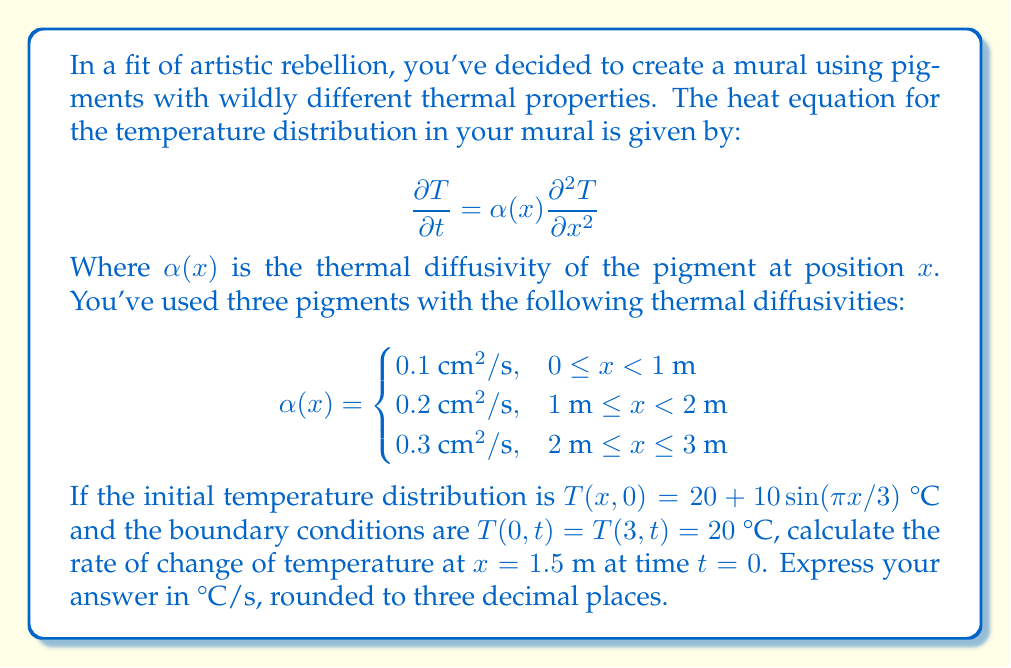Can you answer this question? Let's approach this step-by-step:

1) The rate of change of temperature is given by the left side of the heat equation:

   $$\frac{\partial T}{\partial t} = \alpha(x) \frac{\partial^2 T}{\partial x^2}$$

2) We need to calculate $\frac{\partial^2 T}{\partial x^2}$ at $x = 1.5$ m and $t = 0$.

3) The initial temperature distribution is:
   
   $$T(x,0) = 20 + 10\sin(\pi x/3)$$

4) To find $\frac{\partial^2 T}{\partial x^2}$, we need to differentiate this twice with respect to $x$:

   $$\frac{\partial T}{\partial x} = 10 \cdot \frac{\pi}{3} \cos(\pi x/3)$$
   
   $$\frac{\partial^2 T}{\partial x^2} = 10 \cdot (\frac{\pi}{3})^2 \cdot (-\sin(\pi x/3))$$

5) At $x = 1.5$ m:

   $$\frac{\partial^2 T}{\partial x^2} = 10 \cdot (\frac{\pi}{3})^2 \cdot (-\sin(\pi \cdot 1.5/3))$$
   $$= 10 \cdot (\frac{\pi}{3})^2 \cdot (-\sin(\pi/2))$$
   $$= -10 \cdot (\frac{\pi}{3})^2 \approx -3.290 \text{ °C/m}^2$$

6) At $x = 1.5$ m, we're in the second region where $\alpha(x) = 0.2 \text{ cm}^2/\text{s} = 0.00002 \text{ m}^2/\text{s}$

7) Therefore, the rate of change of temperature is:

   $$\frac{\partial T}{\partial t} = 0.00002 \cdot (-3.290) \approx -0.0000658 \text{ °C/s}$$

8) Rounding to three decimal places: $-0.000$ °C/s
Answer: -0.000 °C/s 